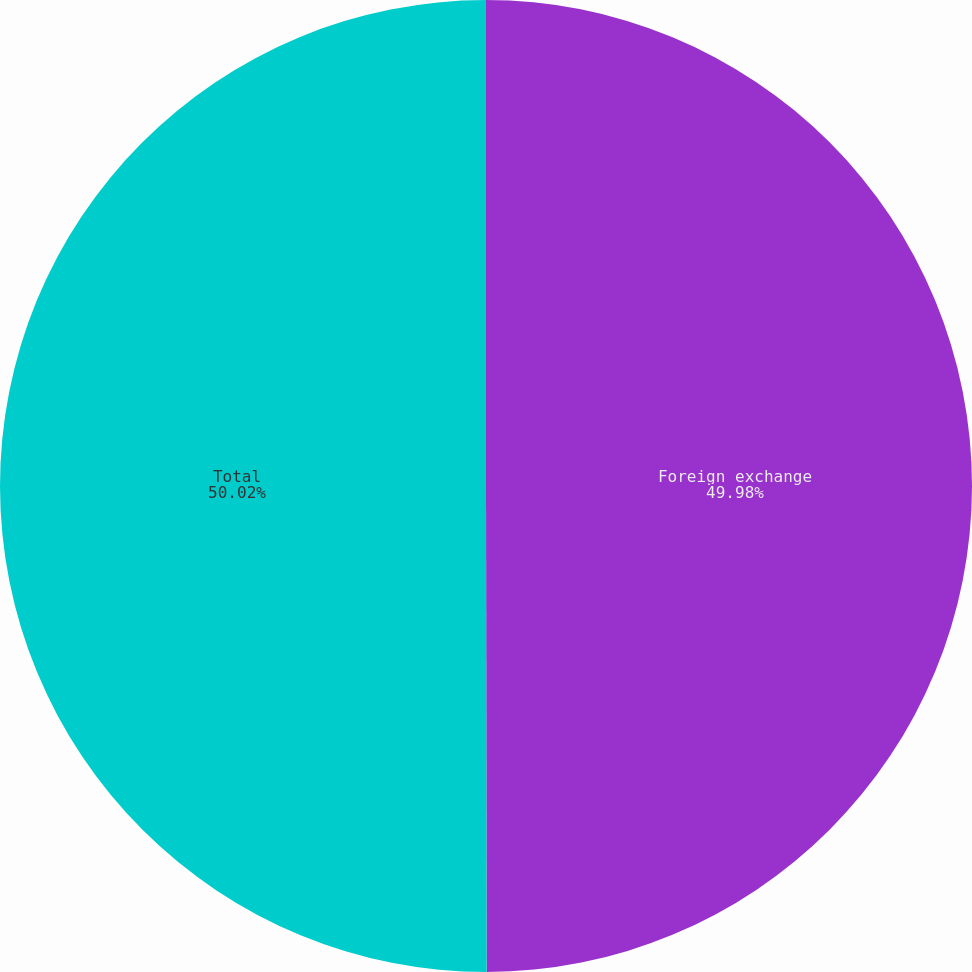<chart> <loc_0><loc_0><loc_500><loc_500><pie_chart><fcel>Foreign exchange<fcel>Total<nl><fcel>49.98%<fcel>50.02%<nl></chart> 